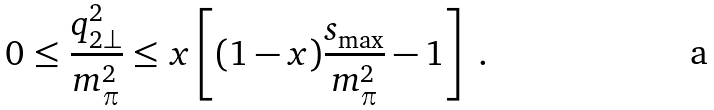Convert formula to latex. <formula><loc_0><loc_0><loc_500><loc_500>0 \leq \frac { q _ { 2 \bot } ^ { 2 } } { m _ { \pi } ^ { 2 } } \leq x \left [ ( 1 - x ) \frac { s _ { \max } } { m _ { \pi } ^ { 2 } } - 1 \right ] \ .</formula> 